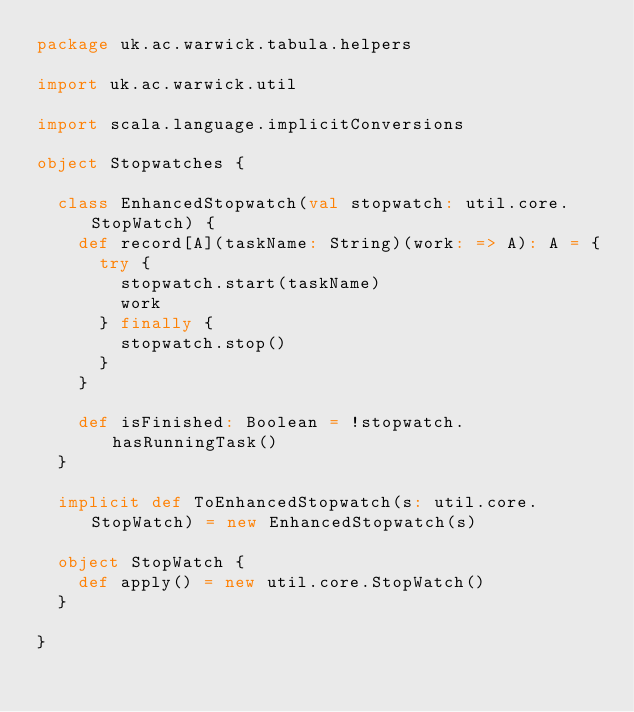Convert code to text. <code><loc_0><loc_0><loc_500><loc_500><_Scala_>package uk.ac.warwick.tabula.helpers

import uk.ac.warwick.util

import scala.language.implicitConversions

object Stopwatches {

  class EnhancedStopwatch(val stopwatch: util.core.StopWatch) {
    def record[A](taskName: String)(work: => A): A = {
      try {
        stopwatch.start(taskName)
        work
      } finally {
        stopwatch.stop()
      }
    }

    def isFinished: Boolean = !stopwatch.hasRunningTask()
  }

  implicit def ToEnhancedStopwatch(s: util.core.StopWatch) = new EnhancedStopwatch(s)

  object StopWatch {
    def apply() = new util.core.StopWatch()
  }

}
</code> 